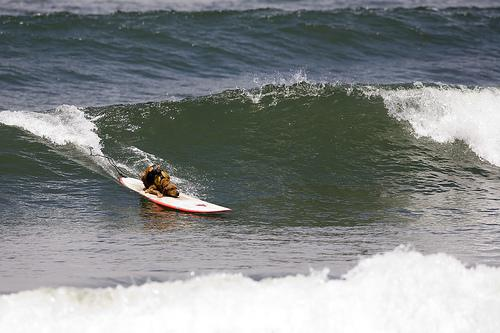Question: where is the dog?
Choices:
A. On the boat.
B. On the beach towel.
C. On the surfboard.
D. In the water.
Answer with the letter. Answer: C Question: what is the dog doing?
Choices:
A. Swimming.
B. Sleeping.
C. Surfing.
D. Eating.
Answer with the letter. Answer: C Question: who is surfing?
Choices:
A. Man.
B. Woman.
C. Dolphin.
D. Dog.
Answer with the letter. Answer: D Question: what color is the water?
Choices:
A. Blue.
B. Gray.
C. Brown.
D. Green.
Answer with the letter. Answer: D 